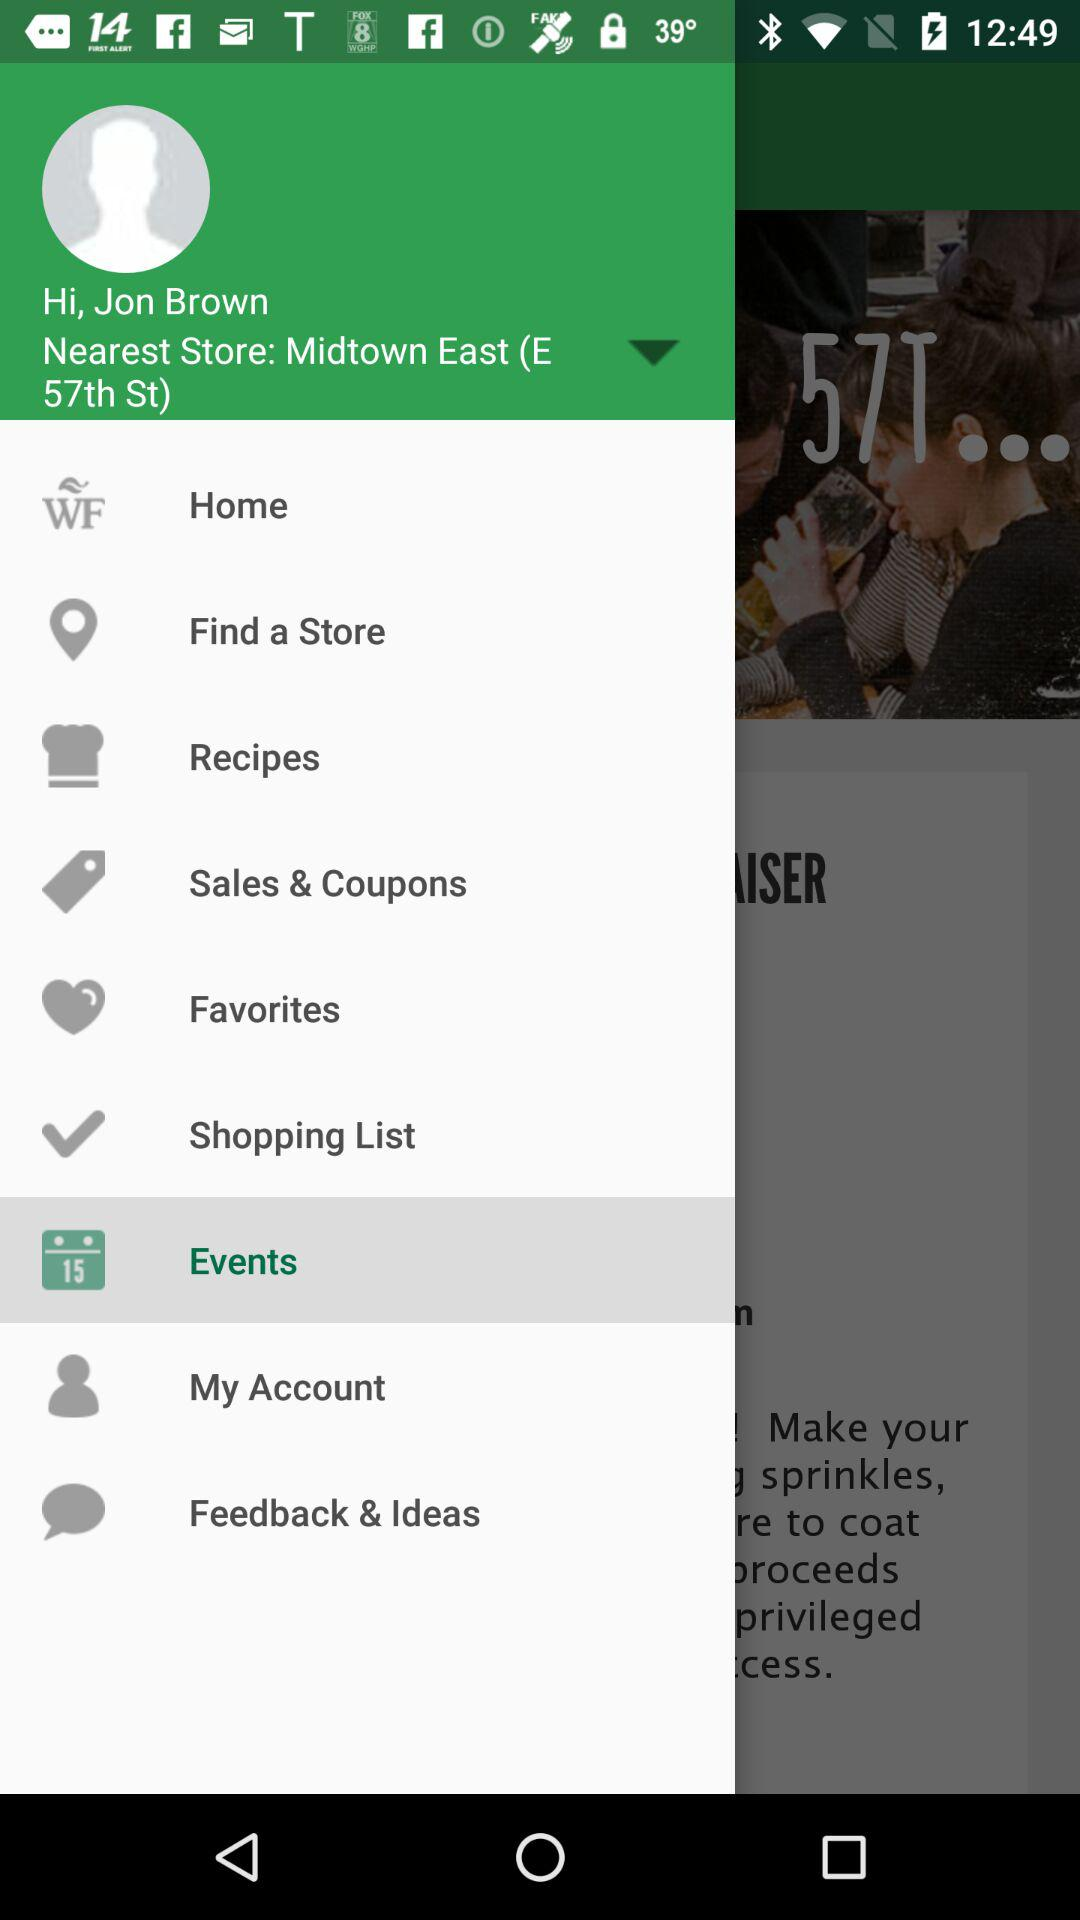What's the user profile name? The user profile name is Jon Brown. 